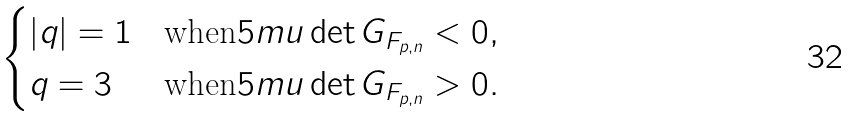Convert formula to latex. <formula><loc_0><loc_0><loc_500><loc_500>\begin{cases} | q | = 1 & \text {when} { 5 m u } \det G _ { F _ { p , n } } < 0 , \\ q = 3 & \text {when} { 5 m u } \det G _ { F _ { p , n } } > 0 . \end{cases}</formula> 